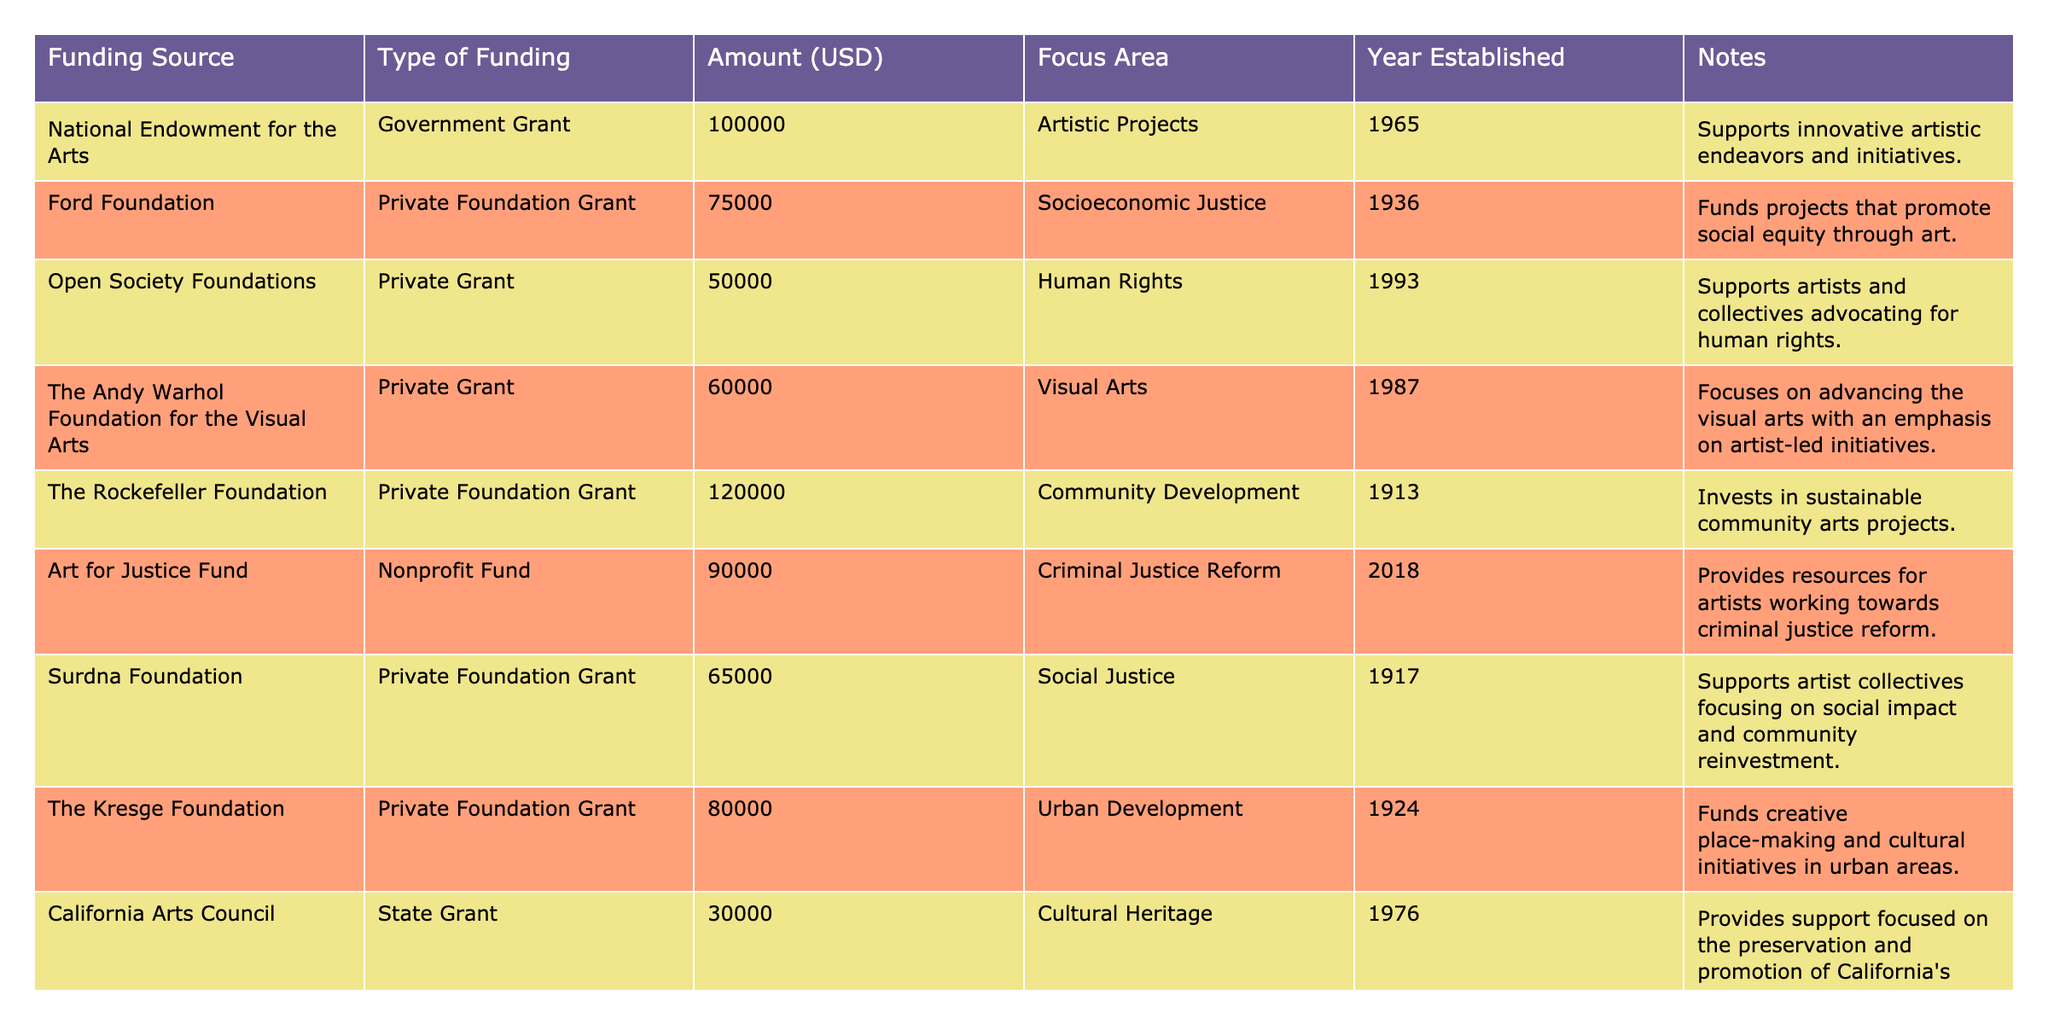What is the total funding amount from private foundations? Private foundations listed include the Ford Foundation, The Rockefeller Foundation, The Andy Warhol Foundation for the Visual Arts, Surdna Foundation, and The Kresge Foundation. Their funding amounts are 75,000, 120,000, 60,000, 65,000, and 80,000 respectively. Adding these gives a total of 75,000 + 120,000 + 60,000 + 65,000 + 80,000 = 400,000.
Answer: 400,000 Which funding source was established most recently? To determine the most recent establishment, we check the Year Established column for the latest year. The Art for Justice Fund was established in 2018, which is the latest year in the list.
Answer: Art for Justice Fund Is the National Endowment for the Arts the only government grant listed in the table? Only one entry falls under the "Government Grant" type, which is the National Endowment for the Arts. Therefore, it is indeed the only government grant listed.
Answer: Yes What is the average funding amount for nonprofit funds? The nonprofit funds are the Art for Justice Fund and The Souls Grown Deep Foundation. Their funding amounts are 90,000 and 40,000. The average is calculated by summing these amounts (90,000 + 40,000 = 130,000) and dividing by the number of nonprofit funds (2). So, 130,000 / 2 = 65,000.
Answer: 65,000 Which focus area has the highest funding source amount? We review the Amount (USD) for each focus area: Artistic Projects (100,000), Socioeconomic Justice (75,000), Human Rights (50,000), Visual Arts (60,000), Community Development (120,000), Criminal Justice Reform (90,000), Social Justice (65,000), Urban Development (80,000), Cultural Heritage (30,000), and Art and Community (40,000). The highest amount is 120,000 for Community Development.
Answer: Community Development How much more funding does the Ford Foundation have compared to the California Arts Council? The Ford Foundation has 75,000 and the California Arts Council has 30,000. The difference is 75,000 - 30,000 = 45,000, indicating that the Ford Foundation provides 45,000 more in funding.
Answer: 45,000 Are there any funding sources with amounts below 50,000? The only funding source with an amount below 50,000 is The Souls Grown Deep Foundation at 40,000. This indicates there are funding sources under that threshold.
Answer: Yes What is the total amount funded for projects related to social justice? The projects related to social justice include the Ford Foundation (75,000), Surdna Foundation (65,000), and Art for Justice Fund (90,000). Adding these amounts together gives 75,000 + 65,000 + 90,000 = 230,000 in total funding for social justice projects.
Answer: 230,000 Which foundation has the least amount of funding and what is its focus area? The foundation with the least amount of funding is The Souls Grown Deep Foundation at 40,000, with a focus on Art and Community.
Answer: The Souls Grown Deep Foundation, Art and Community 